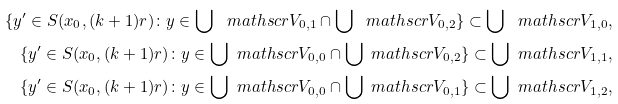Convert formula to latex. <formula><loc_0><loc_0><loc_500><loc_500>\{ y ^ { \prime } \in S ( x _ { 0 } , ( k + 1 ) r ) \colon y \in \bigcup \ m a t h s c r { V } _ { 0 , 1 } \cap \bigcup \ m a t h s c r { V } _ { 0 , 2 } \} \subset \bigcup \ m a t h s c r { V } _ { 1 , 0 } , \\ \{ y ^ { \prime } \in S ( x _ { 0 } , ( k + 1 ) r ) \colon y \in \bigcup \ m a t h s c r { V } _ { 0 , 0 } \cap \bigcup \ m a t h s c r { V } _ { 0 , 2 } \} \subset \bigcup \ m a t h s c r { V } _ { 1 , 1 } , \\ \{ y ^ { \prime } \in S ( x _ { 0 } , ( k + 1 ) r ) \colon y \in \bigcup \ m a t h s c r { V } _ { 0 , 0 } \cap \bigcup \ m a t h s c r { V } _ { 0 , 1 } \} \subset \bigcup \ m a t h s c r { V } _ { 1 , 2 } ,</formula> 